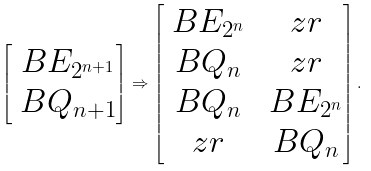<formula> <loc_0><loc_0><loc_500><loc_500>\begin{bmatrix} \ B E _ { 2 ^ { n + 1 } } \\ \ B Q _ { n + 1 } \end{bmatrix} \Rightarrow \begin{bmatrix} \ B E _ { 2 ^ { n } } & \ z r \\ \ B Q _ { n } & \ z r \\ \ B Q _ { n } & \ B E _ { 2 ^ { n } } \\ \ z r & \ B Q _ { n } \end{bmatrix} .</formula> 